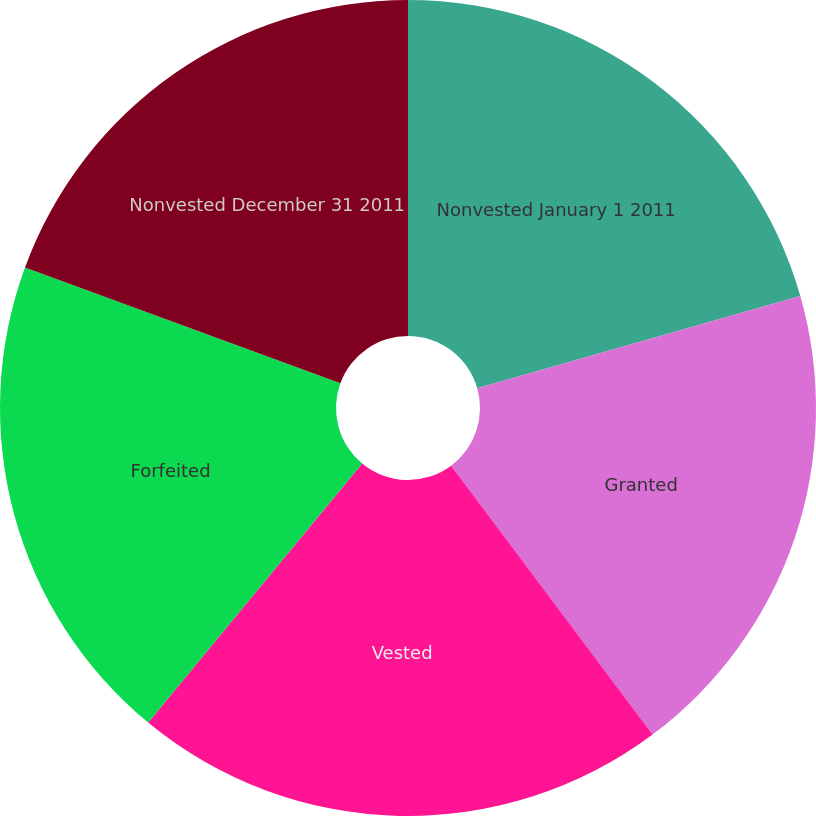<chart> <loc_0><loc_0><loc_500><loc_500><pie_chart><fcel>Nonvested January 1 2011<fcel>Granted<fcel>Vested<fcel>Forfeited<fcel>Nonvested December 31 2011<nl><fcel>20.57%<fcel>19.2%<fcel>21.22%<fcel>19.61%<fcel>19.4%<nl></chart> 